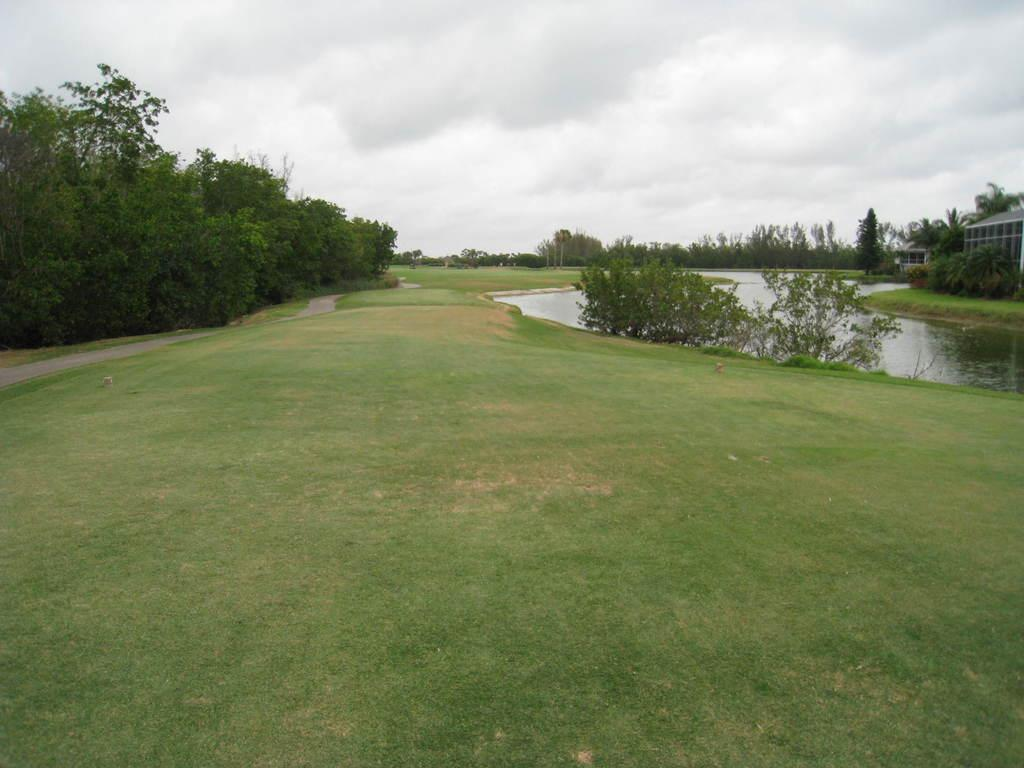What type of vegetation can be seen in the image? There are plants and trees visible in the image. What is the ground surface like in the image? The grass is visible in the image. What natural element can be seen in the image? There is water visible in the image. Are there any man-made structures in the image? Yes, there is a building in the image. What part of the natural environment is visible in the image? The sky is visible in the image. Can you see any fangs in the image? There are no fangs present in the image. What type of grain is being harvested in the image? There is no grain being harvested in the image. 